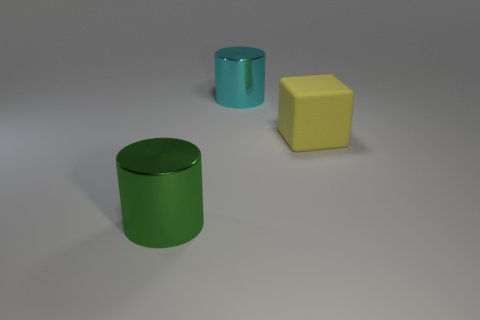Could you tell which objects are made of rubber and which are made of another material? Based on the image, the yellow and the smaller cyan object appear to have a matte surface, which is characteristic of rubber. Therefore, it's likely that these two are made of rubber, while the other cyan cylinder, with a glossier finish, might be made of plastic or metal. 